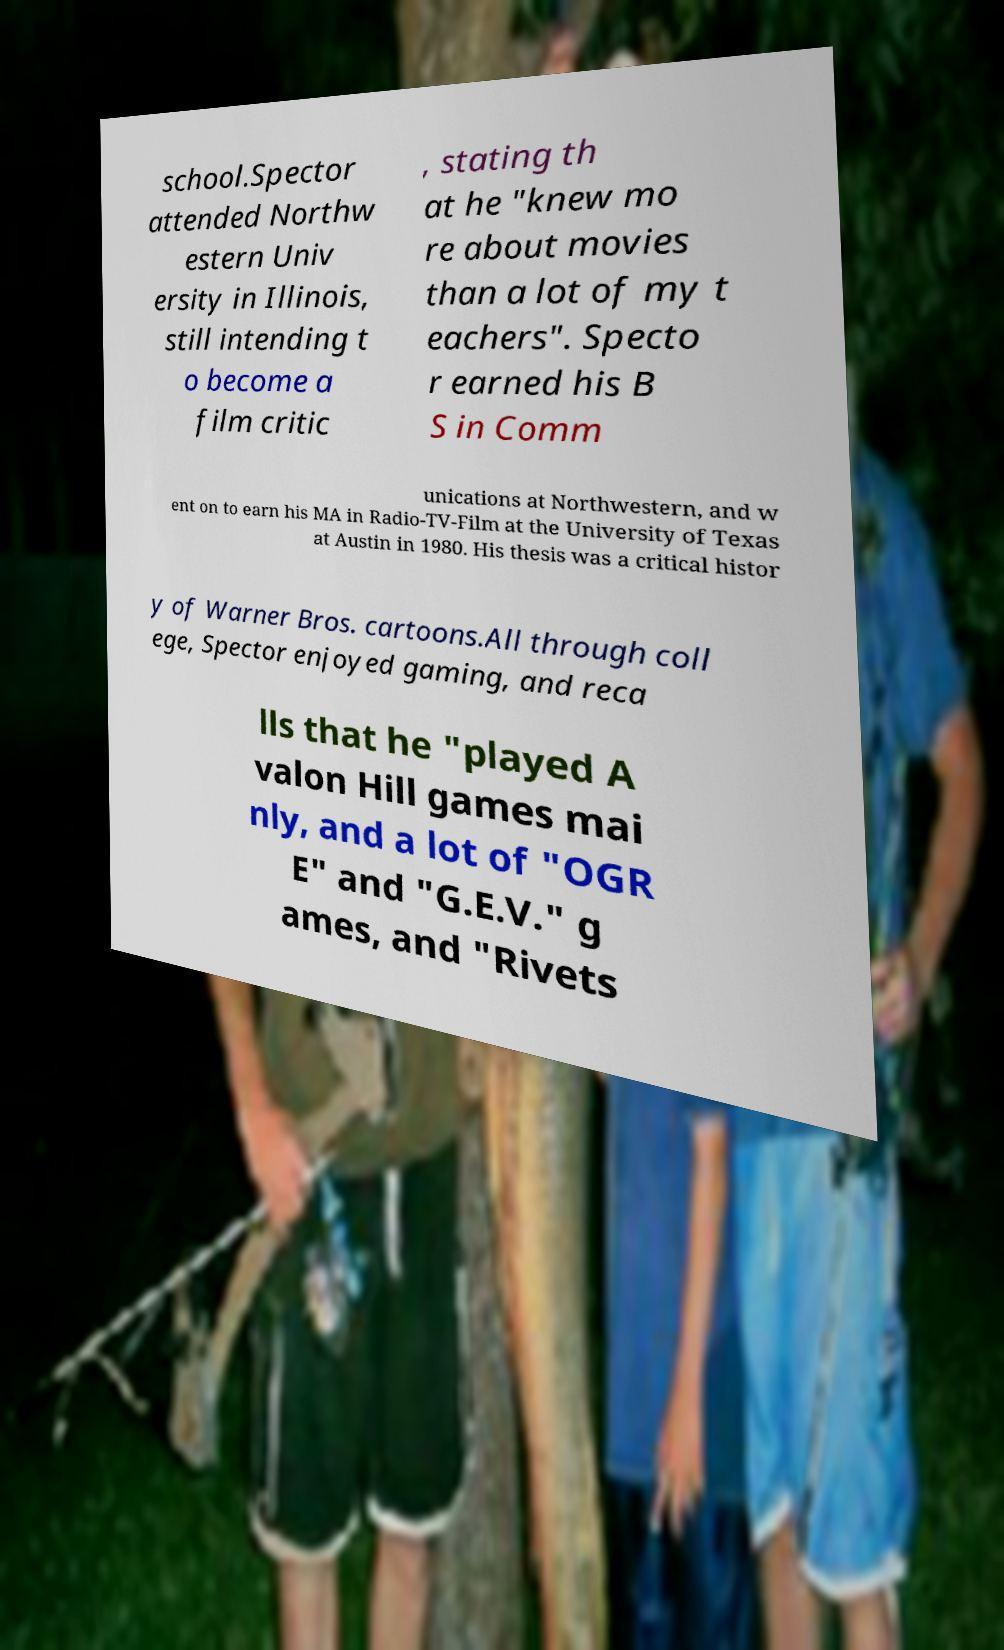What messages or text are displayed in this image? I need them in a readable, typed format. school.Spector attended Northw estern Univ ersity in Illinois, still intending t o become a film critic , stating th at he "knew mo re about movies than a lot of my t eachers". Specto r earned his B S in Comm unications at Northwestern, and w ent on to earn his MA in Radio-TV-Film at the University of Texas at Austin in 1980. His thesis was a critical histor y of Warner Bros. cartoons.All through coll ege, Spector enjoyed gaming, and reca lls that he "played A valon Hill games mai nly, and a lot of "OGR E" and "G.E.V." g ames, and "Rivets 